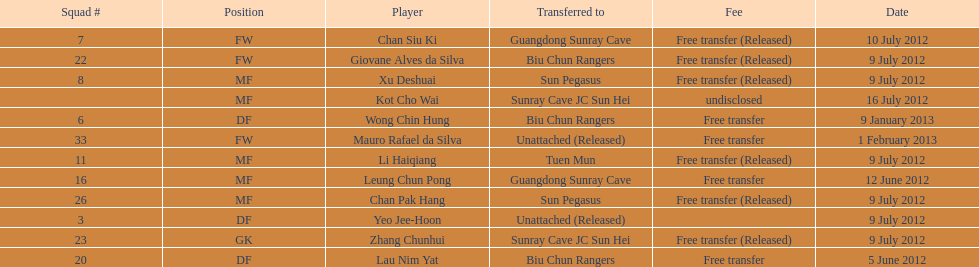What squad # is listed previous to squad # 7? 26. 